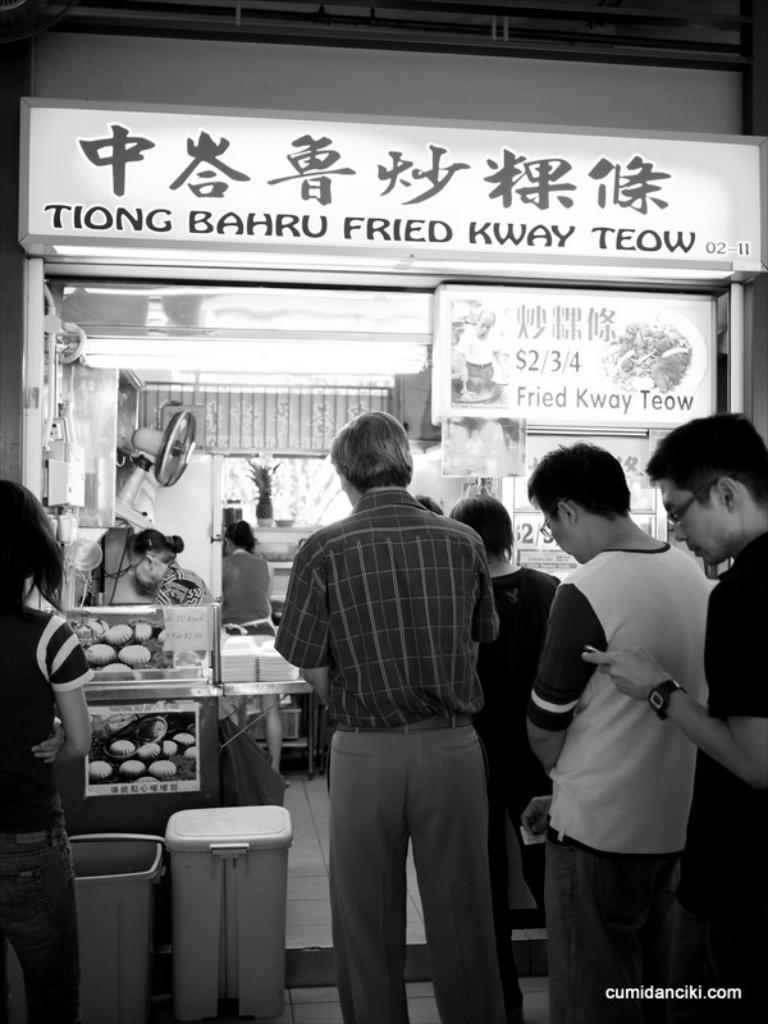<image>
Give a short and clear explanation of the subsequent image. People standing in line in front of a stall named Tiong Bahru Fried Kway Teow. 